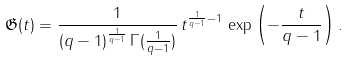<formula> <loc_0><loc_0><loc_500><loc_500>\mathfrak { G } ( t ) = \frac { 1 } { { ( q - 1 ) } ^ { \frac { 1 } { q - 1 } } \, \Gamma ( \frac { 1 } { q - 1 } ) } \, t ^ { \frac { 1 } { q - 1 } - 1 } \, \exp \left ( - \frac { t } { q - 1 } \right ) .</formula> 